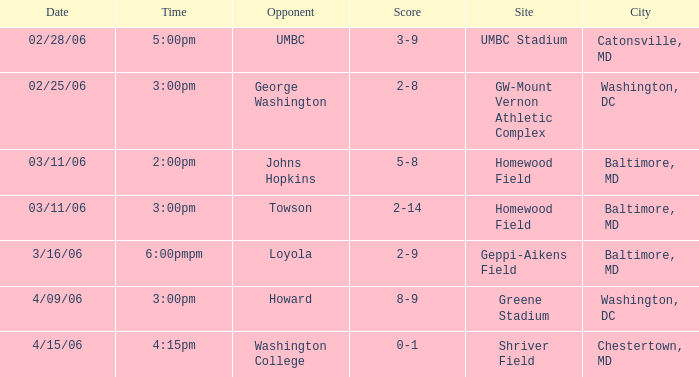What score corresponds to a time of 5:00 pm? 3-9. 